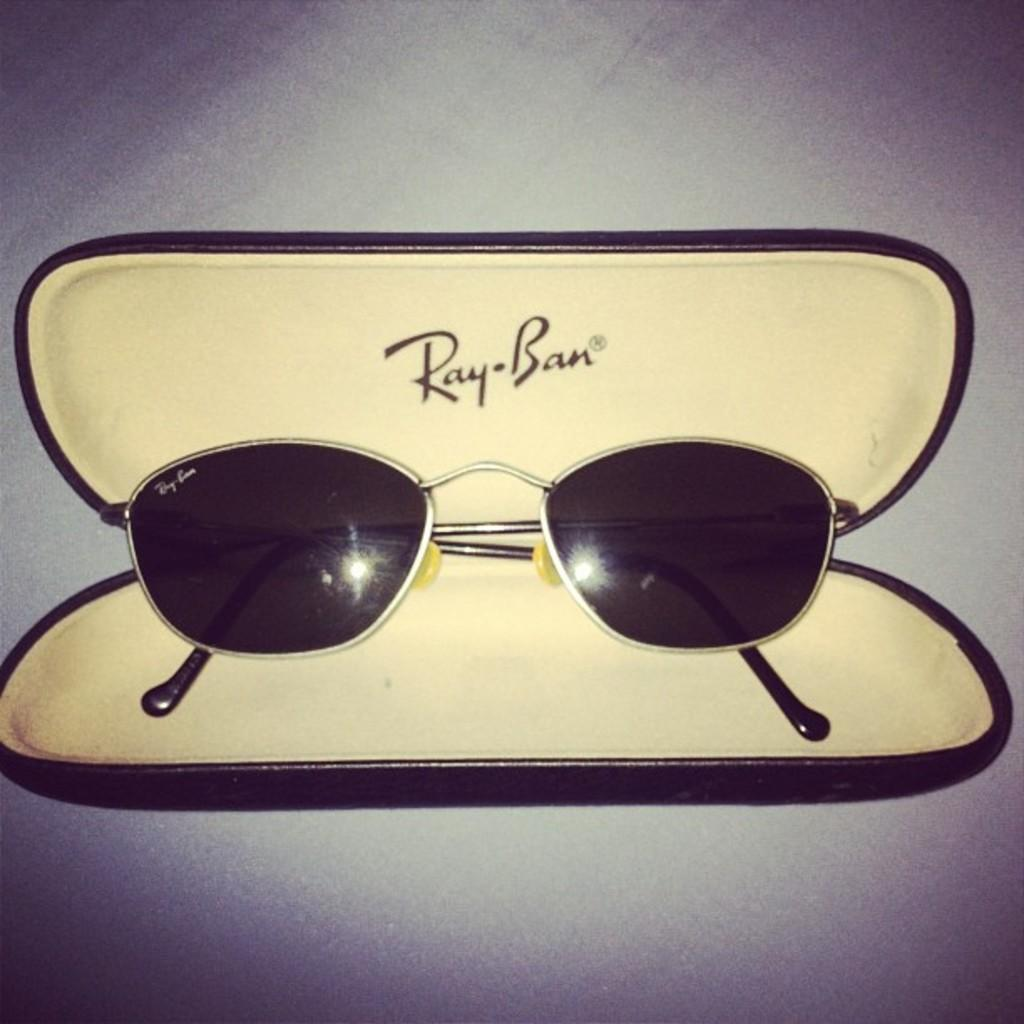What object can be seen in the image? There are sunglasses in the image. Where are the sunglasses located? The sunglasses are in a box. What type of destruction can be seen happening to the ocean in the image? There is no ocean or destruction present in the image; it only features sunglasses in a box. 